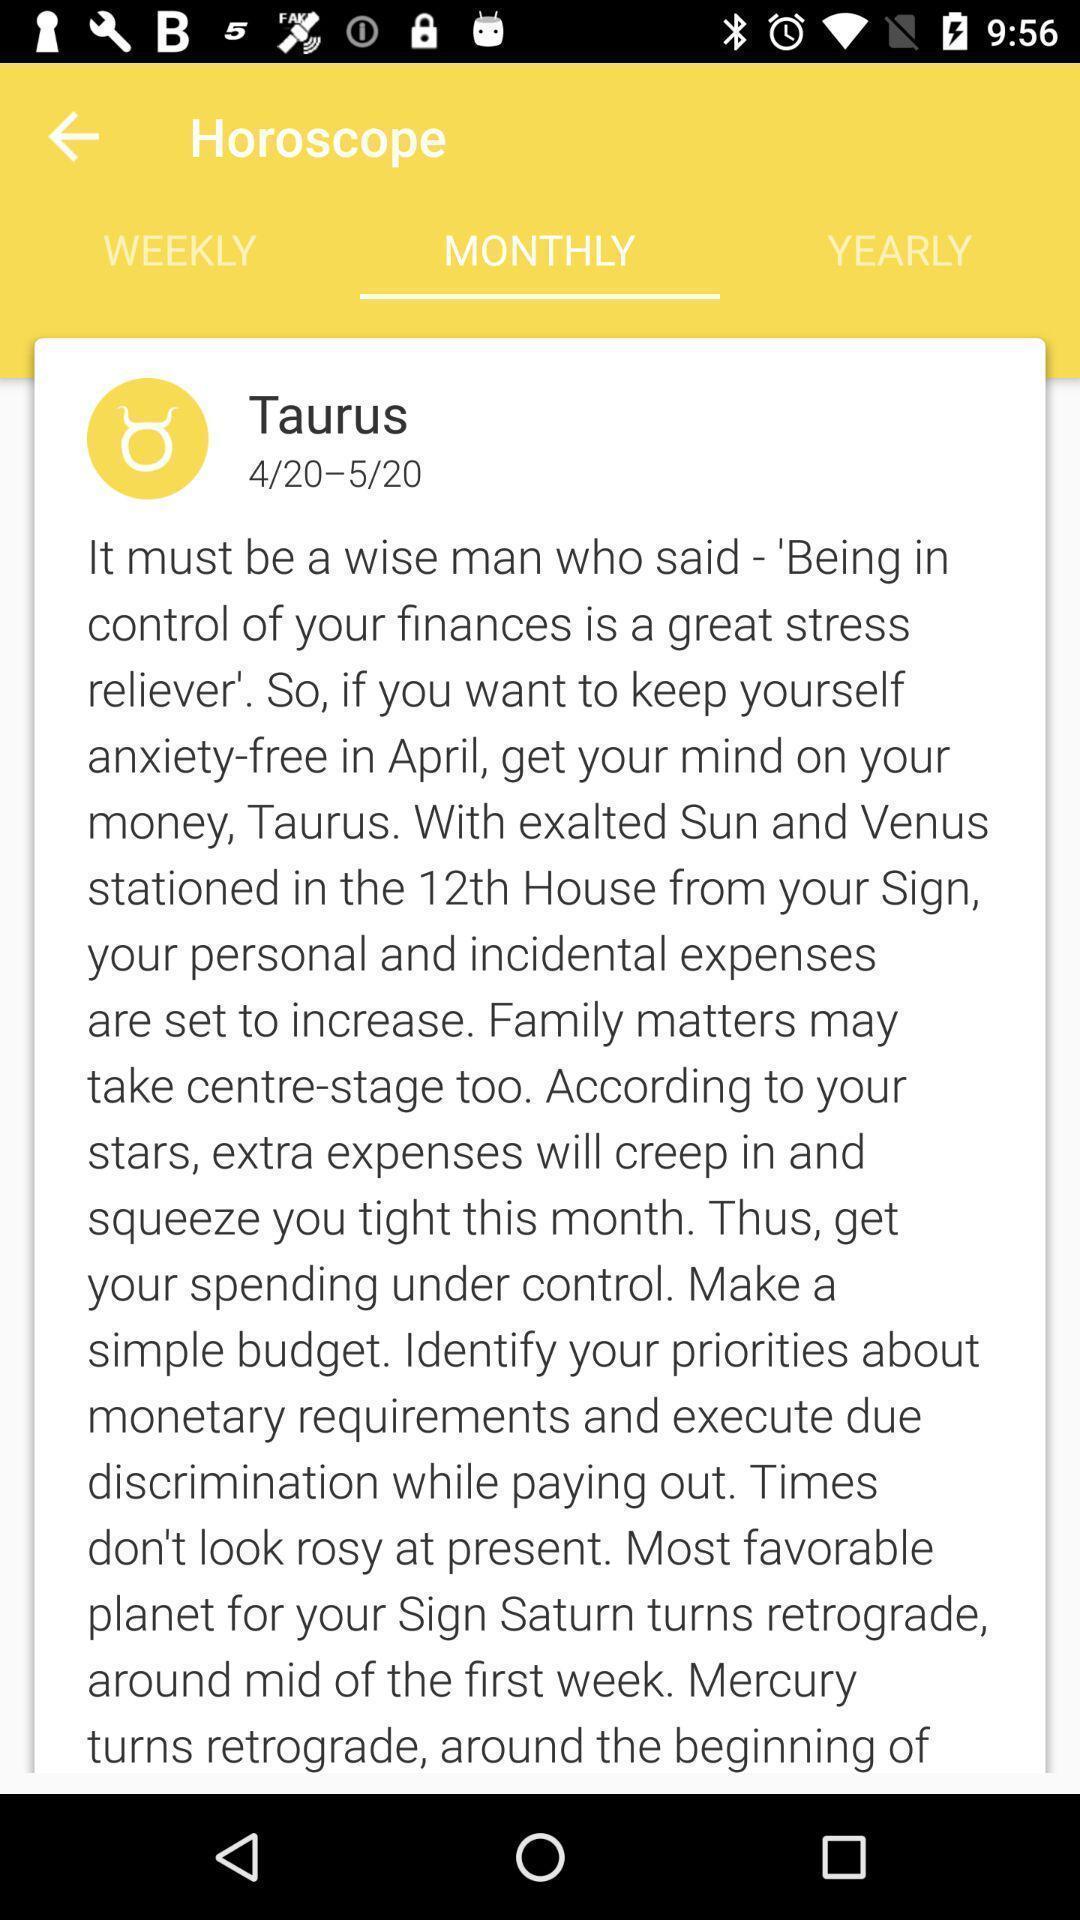Describe the key features of this screenshot. Screen shows horoscope with multiple options. 